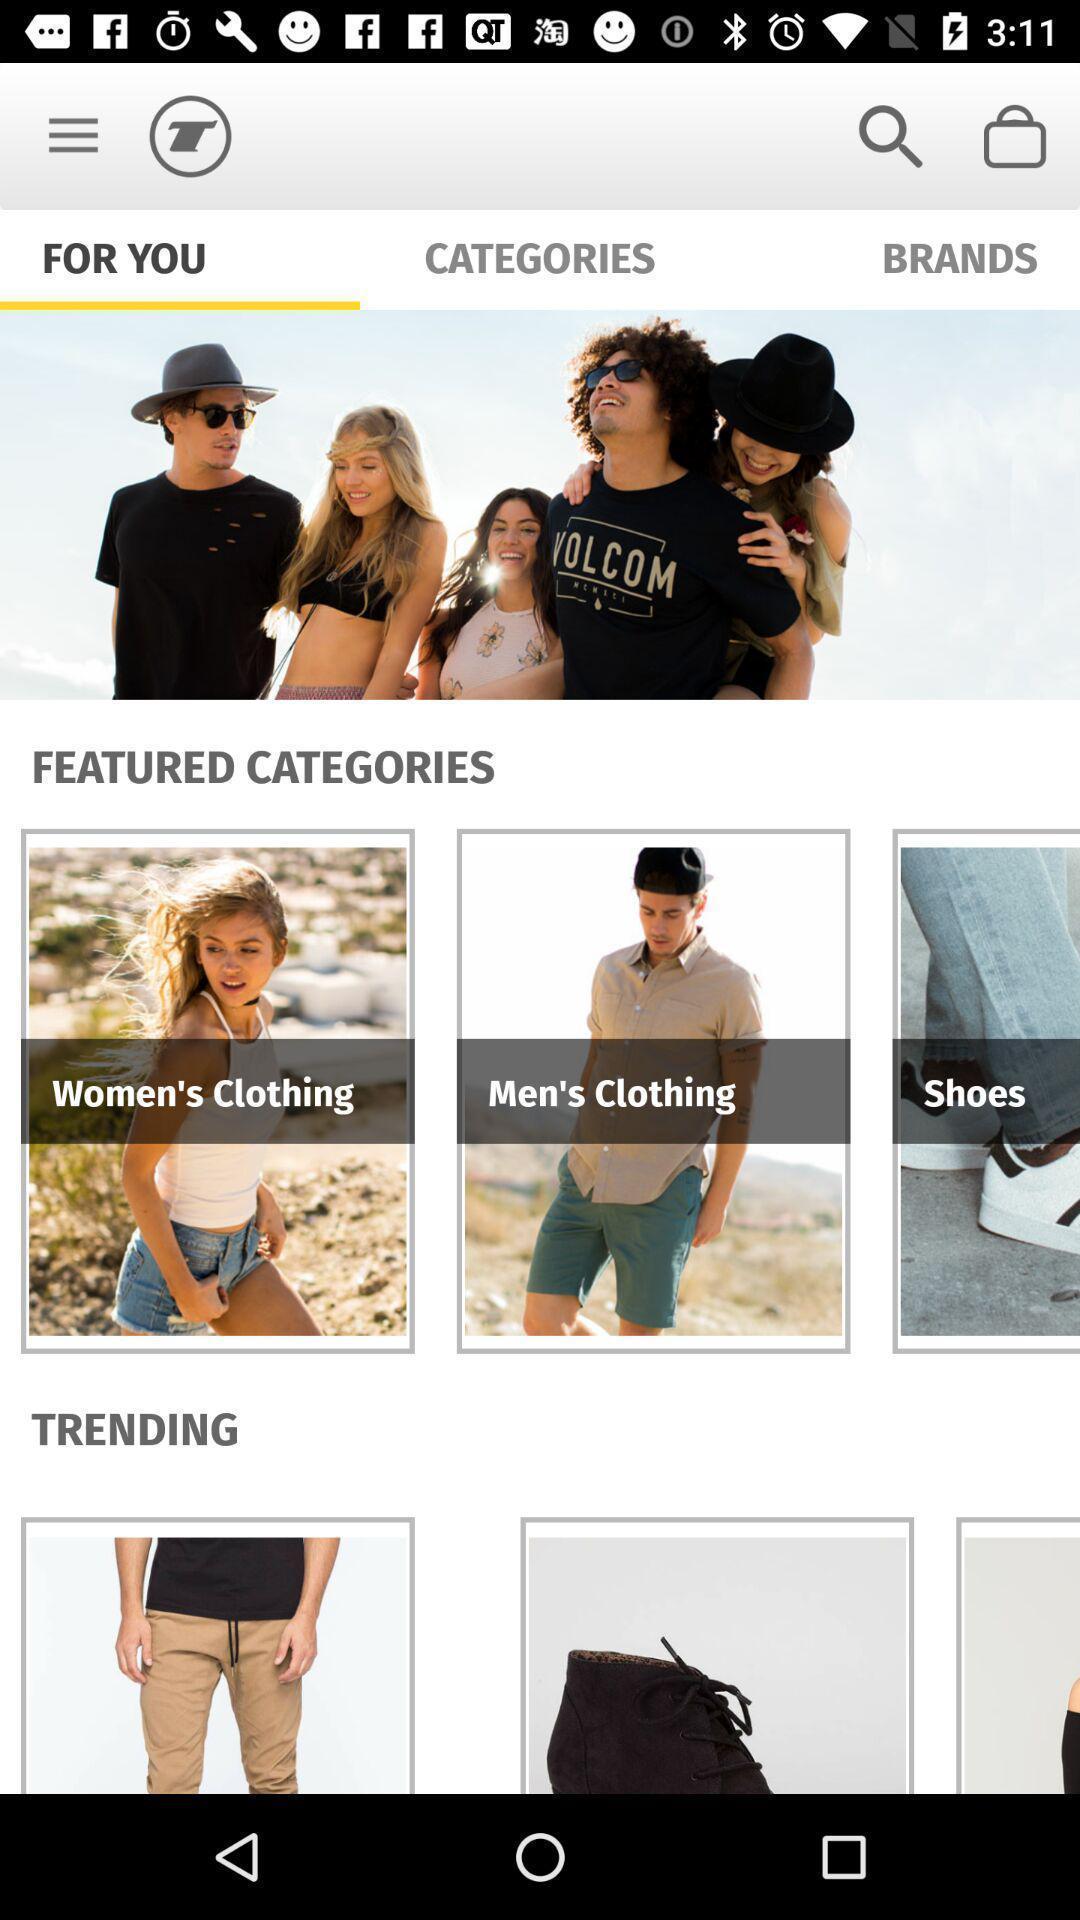Provide a textual representation of this image. Screen displaying shopping lists page. 